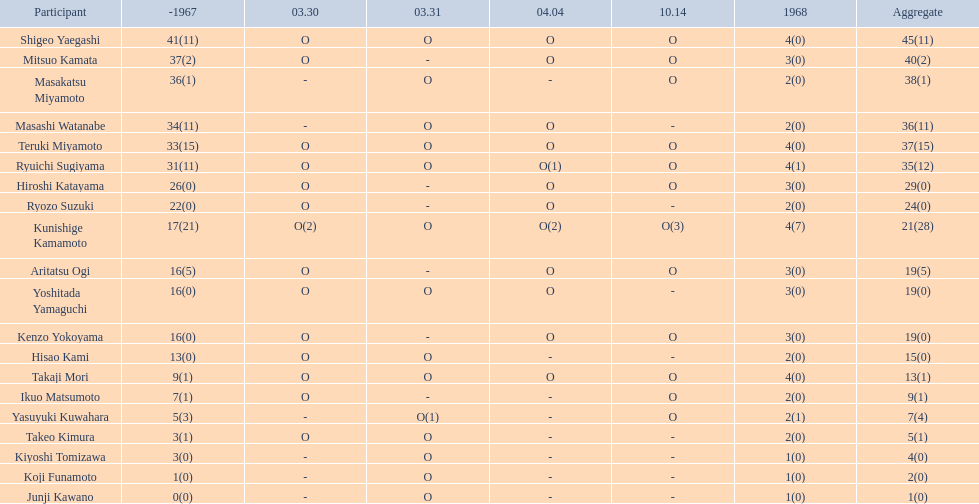Who were the players in the 1968 japanese football? Shigeo Yaegashi, Mitsuo Kamata, Masakatsu Miyamoto, Masashi Watanabe, Teruki Miyamoto, Ryuichi Sugiyama, Hiroshi Katayama, Ryozo Suzuki, Kunishige Kamamoto, Aritatsu Ogi, Yoshitada Yamaguchi, Kenzo Yokoyama, Hisao Kami, Takaji Mori, Ikuo Matsumoto, Yasuyuki Kuwahara, Takeo Kimura, Kiyoshi Tomizawa, Koji Funamoto, Junji Kawano. How many points total did takaji mori have? 13(1). How many points total did junju kawano? 1(0). Who had more points? Takaji Mori. 